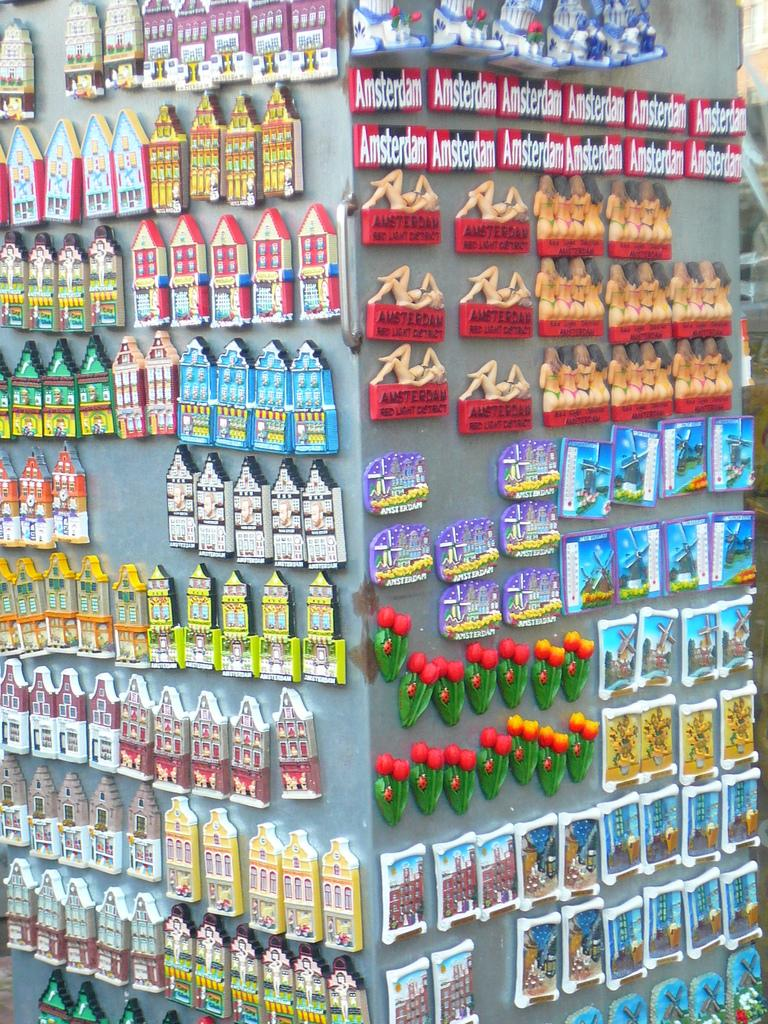<image>
Give a short and clear explanation of the subsequent image. A lot of refrigerator magnets of Amsterdam are on displayed in a store. 